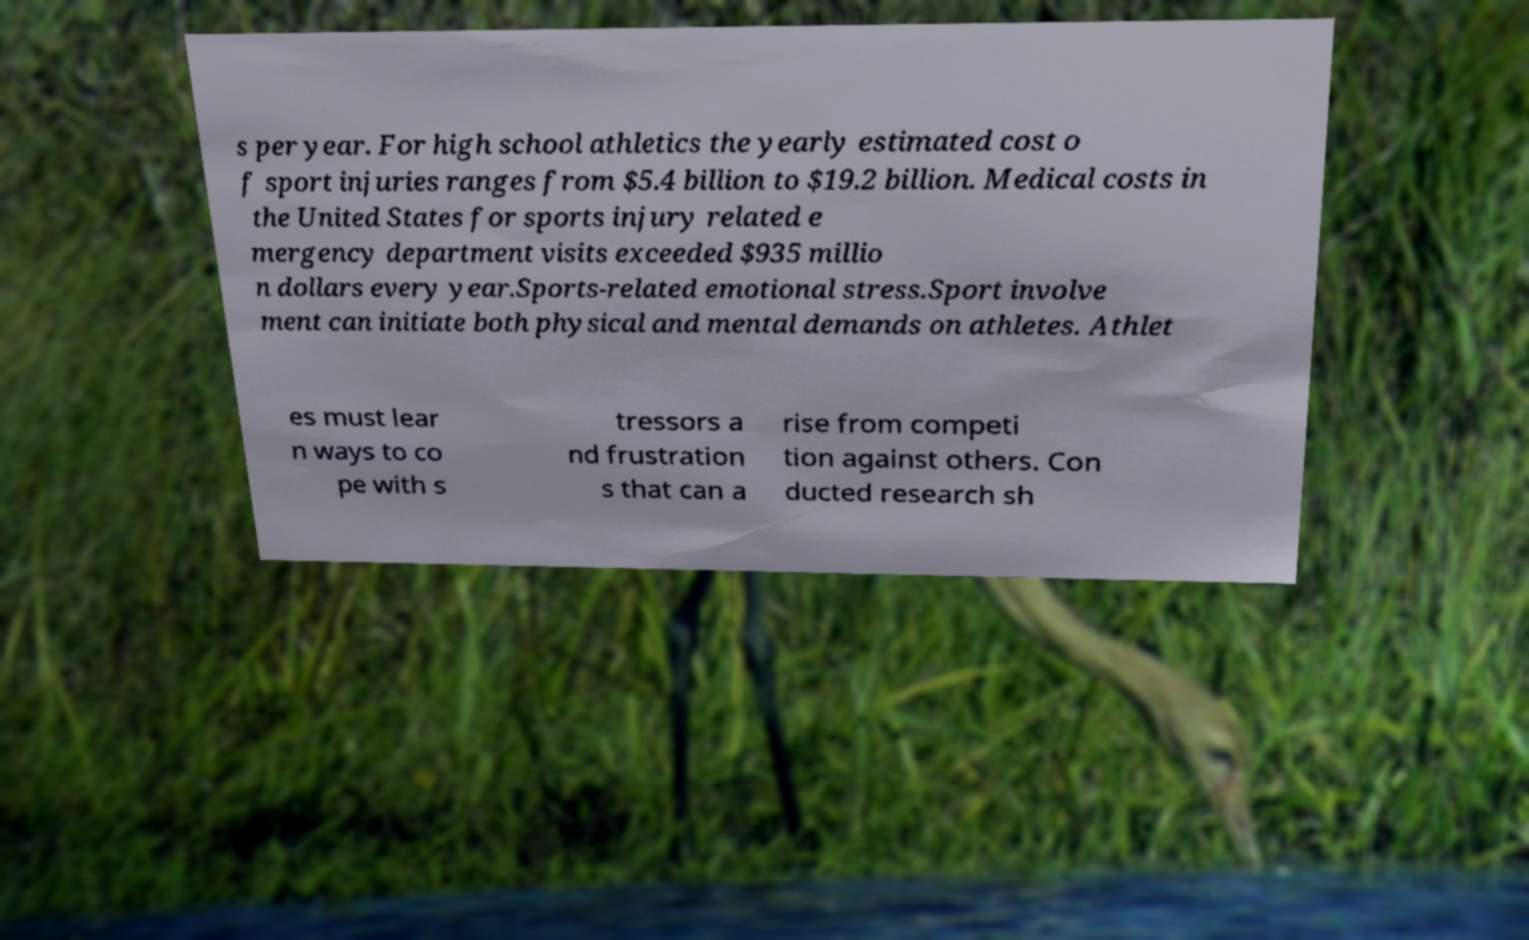Please identify and transcribe the text found in this image. s per year. For high school athletics the yearly estimated cost o f sport injuries ranges from $5.4 billion to $19.2 billion. Medical costs in the United States for sports injury related e mergency department visits exceeded $935 millio n dollars every year.Sports-related emotional stress.Sport involve ment can initiate both physical and mental demands on athletes. Athlet es must lear n ways to co pe with s tressors a nd frustration s that can a rise from competi tion against others. Con ducted research sh 